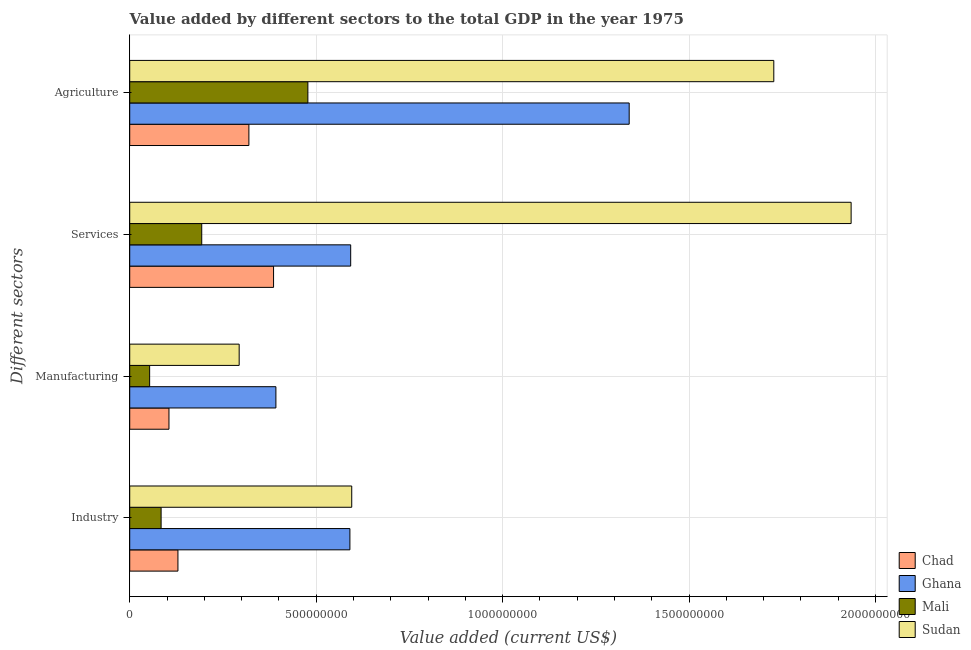How many groups of bars are there?
Your answer should be very brief. 4. Are the number of bars per tick equal to the number of legend labels?
Ensure brevity in your answer.  Yes. Are the number of bars on each tick of the Y-axis equal?
Make the answer very short. Yes. How many bars are there on the 3rd tick from the top?
Give a very brief answer. 4. How many bars are there on the 4th tick from the bottom?
Give a very brief answer. 4. What is the label of the 3rd group of bars from the top?
Your response must be concise. Manufacturing. What is the value added by services sector in Chad?
Your answer should be very brief. 3.86e+08. Across all countries, what is the maximum value added by services sector?
Your answer should be very brief. 1.93e+09. Across all countries, what is the minimum value added by industrial sector?
Keep it short and to the point. 8.42e+07. In which country was the value added by industrial sector maximum?
Ensure brevity in your answer.  Sudan. In which country was the value added by services sector minimum?
Provide a succinct answer. Mali. What is the total value added by industrial sector in the graph?
Offer a very short reply. 1.40e+09. What is the difference between the value added by industrial sector in Sudan and that in Chad?
Offer a very short reply. 4.66e+08. What is the difference between the value added by manufacturing sector in Chad and the value added by agricultural sector in Ghana?
Offer a terse response. -1.23e+09. What is the average value added by services sector per country?
Your response must be concise. 7.76e+08. What is the difference between the value added by agricultural sector and value added by manufacturing sector in Sudan?
Provide a short and direct response. 1.43e+09. In how many countries, is the value added by agricultural sector greater than 1600000000 US$?
Make the answer very short. 1. What is the ratio of the value added by agricultural sector in Mali to that in Chad?
Provide a short and direct response. 1.5. What is the difference between the highest and the second highest value added by industrial sector?
Provide a short and direct response. 4.92e+06. What is the difference between the highest and the lowest value added by agricultural sector?
Provide a succinct answer. 1.41e+09. Is it the case that in every country, the sum of the value added by industrial sector and value added by agricultural sector is greater than the sum of value added by manufacturing sector and value added by services sector?
Provide a short and direct response. No. What does the 4th bar from the top in Agriculture represents?
Offer a very short reply. Chad. What does the 4th bar from the bottom in Manufacturing represents?
Give a very brief answer. Sudan. Is it the case that in every country, the sum of the value added by industrial sector and value added by manufacturing sector is greater than the value added by services sector?
Ensure brevity in your answer.  No. What is the difference between two consecutive major ticks on the X-axis?
Offer a terse response. 5.00e+08. Are the values on the major ticks of X-axis written in scientific E-notation?
Your response must be concise. No. How many legend labels are there?
Give a very brief answer. 4. How are the legend labels stacked?
Your answer should be very brief. Vertical. What is the title of the graph?
Provide a short and direct response. Value added by different sectors to the total GDP in the year 1975. Does "Switzerland" appear as one of the legend labels in the graph?
Your response must be concise. No. What is the label or title of the X-axis?
Keep it short and to the point. Value added (current US$). What is the label or title of the Y-axis?
Provide a succinct answer. Different sectors. What is the Value added (current US$) in Chad in Industry?
Make the answer very short. 1.29e+08. What is the Value added (current US$) in Ghana in Industry?
Make the answer very short. 5.90e+08. What is the Value added (current US$) of Mali in Industry?
Ensure brevity in your answer.  8.42e+07. What is the Value added (current US$) in Sudan in Industry?
Offer a terse response. 5.95e+08. What is the Value added (current US$) in Chad in Manufacturing?
Your response must be concise. 1.05e+08. What is the Value added (current US$) of Ghana in Manufacturing?
Make the answer very short. 3.92e+08. What is the Value added (current US$) of Mali in Manufacturing?
Ensure brevity in your answer.  5.34e+07. What is the Value added (current US$) in Sudan in Manufacturing?
Your answer should be compact. 2.94e+08. What is the Value added (current US$) of Chad in Services?
Give a very brief answer. 3.86e+08. What is the Value added (current US$) of Ghana in Services?
Provide a short and direct response. 5.93e+08. What is the Value added (current US$) in Mali in Services?
Your answer should be compact. 1.93e+08. What is the Value added (current US$) in Sudan in Services?
Ensure brevity in your answer.  1.93e+09. What is the Value added (current US$) of Chad in Agriculture?
Your answer should be very brief. 3.20e+08. What is the Value added (current US$) in Ghana in Agriculture?
Make the answer very short. 1.34e+09. What is the Value added (current US$) in Mali in Agriculture?
Your answer should be very brief. 4.78e+08. What is the Value added (current US$) of Sudan in Agriculture?
Make the answer very short. 1.73e+09. Across all Different sectors, what is the maximum Value added (current US$) of Chad?
Provide a short and direct response. 3.86e+08. Across all Different sectors, what is the maximum Value added (current US$) of Ghana?
Provide a short and direct response. 1.34e+09. Across all Different sectors, what is the maximum Value added (current US$) in Mali?
Offer a very short reply. 4.78e+08. Across all Different sectors, what is the maximum Value added (current US$) of Sudan?
Your response must be concise. 1.93e+09. Across all Different sectors, what is the minimum Value added (current US$) of Chad?
Your answer should be very brief. 1.05e+08. Across all Different sectors, what is the minimum Value added (current US$) of Ghana?
Your response must be concise. 3.92e+08. Across all Different sectors, what is the minimum Value added (current US$) in Mali?
Ensure brevity in your answer.  5.34e+07. Across all Different sectors, what is the minimum Value added (current US$) in Sudan?
Ensure brevity in your answer.  2.94e+08. What is the total Value added (current US$) of Chad in the graph?
Keep it short and to the point. 9.40e+08. What is the total Value added (current US$) of Ghana in the graph?
Provide a short and direct response. 2.91e+09. What is the total Value added (current US$) in Mali in the graph?
Provide a succinct answer. 8.08e+08. What is the total Value added (current US$) in Sudan in the graph?
Provide a succinct answer. 4.55e+09. What is the difference between the Value added (current US$) of Chad in Industry and that in Manufacturing?
Make the answer very short. 2.41e+07. What is the difference between the Value added (current US$) of Ghana in Industry and that in Manufacturing?
Provide a short and direct response. 1.98e+08. What is the difference between the Value added (current US$) of Mali in Industry and that in Manufacturing?
Keep it short and to the point. 3.08e+07. What is the difference between the Value added (current US$) in Sudan in Industry and that in Manufacturing?
Your answer should be compact. 3.02e+08. What is the difference between the Value added (current US$) in Chad in Industry and that in Services?
Provide a short and direct response. -2.56e+08. What is the difference between the Value added (current US$) in Ghana in Industry and that in Services?
Your response must be concise. -2.13e+06. What is the difference between the Value added (current US$) in Mali in Industry and that in Services?
Provide a succinct answer. -1.09e+08. What is the difference between the Value added (current US$) in Sudan in Industry and that in Services?
Offer a terse response. -1.34e+09. What is the difference between the Value added (current US$) in Chad in Industry and that in Agriculture?
Your response must be concise. -1.90e+08. What is the difference between the Value added (current US$) of Ghana in Industry and that in Agriculture?
Provide a short and direct response. -7.49e+08. What is the difference between the Value added (current US$) of Mali in Industry and that in Agriculture?
Provide a succinct answer. -3.94e+08. What is the difference between the Value added (current US$) in Sudan in Industry and that in Agriculture?
Make the answer very short. -1.13e+09. What is the difference between the Value added (current US$) of Chad in Manufacturing and that in Services?
Offer a terse response. -2.80e+08. What is the difference between the Value added (current US$) in Ghana in Manufacturing and that in Services?
Provide a short and direct response. -2.01e+08. What is the difference between the Value added (current US$) of Mali in Manufacturing and that in Services?
Provide a short and direct response. -1.40e+08. What is the difference between the Value added (current US$) of Sudan in Manufacturing and that in Services?
Your answer should be very brief. -1.64e+09. What is the difference between the Value added (current US$) of Chad in Manufacturing and that in Agriculture?
Provide a succinct answer. -2.14e+08. What is the difference between the Value added (current US$) in Ghana in Manufacturing and that in Agriculture?
Provide a succinct answer. -9.47e+08. What is the difference between the Value added (current US$) in Mali in Manufacturing and that in Agriculture?
Keep it short and to the point. -4.24e+08. What is the difference between the Value added (current US$) of Sudan in Manufacturing and that in Agriculture?
Your answer should be very brief. -1.43e+09. What is the difference between the Value added (current US$) in Chad in Services and that in Agriculture?
Keep it short and to the point. 6.62e+07. What is the difference between the Value added (current US$) in Ghana in Services and that in Agriculture?
Keep it short and to the point. -7.47e+08. What is the difference between the Value added (current US$) of Mali in Services and that in Agriculture?
Provide a succinct answer. -2.85e+08. What is the difference between the Value added (current US$) in Sudan in Services and that in Agriculture?
Your answer should be very brief. 2.07e+08. What is the difference between the Value added (current US$) in Chad in Industry and the Value added (current US$) in Ghana in Manufacturing?
Your answer should be very brief. -2.63e+08. What is the difference between the Value added (current US$) of Chad in Industry and the Value added (current US$) of Mali in Manufacturing?
Provide a short and direct response. 7.59e+07. What is the difference between the Value added (current US$) in Chad in Industry and the Value added (current US$) in Sudan in Manufacturing?
Your response must be concise. -1.64e+08. What is the difference between the Value added (current US$) of Ghana in Industry and the Value added (current US$) of Mali in Manufacturing?
Keep it short and to the point. 5.37e+08. What is the difference between the Value added (current US$) in Ghana in Industry and the Value added (current US$) in Sudan in Manufacturing?
Offer a terse response. 2.97e+08. What is the difference between the Value added (current US$) in Mali in Industry and the Value added (current US$) in Sudan in Manufacturing?
Provide a succinct answer. -2.09e+08. What is the difference between the Value added (current US$) of Chad in Industry and the Value added (current US$) of Ghana in Services?
Ensure brevity in your answer.  -4.63e+08. What is the difference between the Value added (current US$) in Chad in Industry and the Value added (current US$) in Mali in Services?
Provide a succinct answer. -6.38e+07. What is the difference between the Value added (current US$) of Chad in Industry and the Value added (current US$) of Sudan in Services?
Your response must be concise. -1.81e+09. What is the difference between the Value added (current US$) in Ghana in Industry and the Value added (current US$) in Mali in Services?
Ensure brevity in your answer.  3.97e+08. What is the difference between the Value added (current US$) of Ghana in Industry and the Value added (current US$) of Sudan in Services?
Your answer should be compact. -1.34e+09. What is the difference between the Value added (current US$) in Mali in Industry and the Value added (current US$) in Sudan in Services?
Ensure brevity in your answer.  -1.85e+09. What is the difference between the Value added (current US$) in Chad in Industry and the Value added (current US$) in Ghana in Agriculture?
Your response must be concise. -1.21e+09. What is the difference between the Value added (current US$) in Chad in Industry and the Value added (current US$) in Mali in Agriculture?
Make the answer very short. -3.48e+08. What is the difference between the Value added (current US$) of Chad in Industry and the Value added (current US$) of Sudan in Agriculture?
Provide a short and direct response. -1.60e+09. What is the difference between the Value added (current US$) in Ghana in Industry and the Value added (current US$) in Mali in Agriculture?
Offer a very short reply. 1.13e+08. What is the difference between the Value added (current US$) in Ghana in Industry and the Value added (current US$) in Sudan in Agriculture?
Make the answer very short. -1.14e+09. What is the difference between the Value added (current US$) of Mali in Industry and the Value added (current US$) of Sudan in Agriculture?
Provide a short and direct response. -1.64e+09. What is the difference between the Value added (current US$) of Chad in Manufacturing and the Value added (current US$) of Ghana in Services?
Your answer should be very brief. -4.87e+08. What is the difference between the Value added (current US$) of Chad in Manufacturing and the Value added (current US$) of Mali in Services?
Offer a terse response. -8.79e+07. What is the difference between the Value added (current US$) in Chad in Manufacturing and the Value added (current US$) in Sudan in Services?
Your answer should be compact. -1.83e+09. What is the difference between the Value added (current US$) in Ghana in Manufacturing and the Value added (current US$) in Mali in Services?
Make the answer very short. 1.99e+08. What is the difference between the Value added (current US$) of Ghana in Manufacturing and the Value added (current US$) of Sudan in Services?
Provide a succinct answer. -1.54e+09. What is the difference between the Value added (current US$) of Mali in Manufacturing and the Value added (current US$) of Sudan in Services?
Your answer should be compact. -1.88e+09. What is the difference between the Value added (current US$) in Chad in Manufacturing and the Value added (current US$) in Ghana in Agriculture?
Provide a short and direct response. -1.23e+09. What is the difference between the Value added (current US$) of Chad in Manufacturing and the Value added (current US$) of Mali in Agriculture?
Make the answer very short. -3.72e+08. What is the difference between the Value added (current US$) in Chad in Manufacturing and the Value added (current US$) in Sudan in Agriculture?
Provide a succinct answer. -1.62e+09. What is the difference between the Value added (current US$) in Ghana in Manufacturing and the Value added (current US$) in Mali in Agriculture?
Ensure brevity in your answer.  -8.57e+07. What is the difference between the Value added (current US$) in Ghana in Manufacturing and the Value added (current US$) in Sudan in Agriculture?
Provide a short and direct response. -1.34e+09. What is the difference between the Value added (current US$) in Mali in Manufacturing and the Value added (current US$) in Sudan in Agriculture?
Give a very brief answer. -1.67e+09. What is the difference between the Value added (current US$) of Chad in Services and the Value added (current US$) of Ghana in Agriculture?
Your answer should be compact. -9.54e+08. What is the difference between the Value added (current US$) in Chad in Services and the Value added (current US$) in Mali in Agriculture?
Provide a succinct answer. -9.20e+07. What is the difference between the Value added (current US$) in Chad in Services and the Value added (current US$) in Sudan in Agriculture?
Offer a terse response. -1.34e+09. What is the difference between the Value added (current US$) in Ghana in Services and the Value added (current US$) in Mali in Agriculture?
Keep it short and to the point. 1.15e+08. What is the difference between the Value added (current US$) in Ghana in Services and the Value added (current US$) in Sudan in Agriculture?
Your answer should be very brief. -1.13e+09. What is the difference between the Value added (current US$) of Mali in Services and the Value added (current US$) of Sudan in Agriculture?
Provide a short and direct response. -1.53e+09. What is the average Value added (current US$) in Chad per Different sectors?
Give a very brief answer. 2.35e+08. What is the average Value added (current US$) of Ghana per Different sectors?
Keep it short and to the point. 7.29e+08. What is the average Value added (current US$) of Mali per Different sectors?
Keep it short and to the point. 2.02e+08. What is the average Value added (current US$) of Sudan per Different sectors?
Provide a short and direct response. 1.14e+09. What is the difference between the Value added (current US$) in Chad and Value added (current US$) in Ghana in Industry?
Offer a very short reply. -4.61e+08. What is the difference between the Value added (current US$) of Chad and Value added (current US$) of Mali in Industry?
Your answer should be compact. 4.51e+07. What is the difference between the Value added (current US$) of Chad and Value added (current US$) of Sudan in Industry?
Your answer should be compact. -4.66e+08. What is the difference between the Value added (current US$) in Ghana and Value added (current US$) in Mali in Industry?
Give a very brief answer. 5.06e+08. What is the difference between the Value added (current US$) of Ghana and Value added (current US$) of Sudan in Industry?
Provide a short and direct response. -4.92e+06. What is the difference between the Value added (current US$) of Mali and Value added (current US$) of Sudan in Industry?
Your answer should be very brief. -5.11e+08. What is the difference between the Value added (current US$) of Chad and Value added (current US$) of Ghana in Manufacturing?
Your answer should be very brief. -2.87e+08. What is the difference between the Value added (current US$) of Chad and Value added (current US$) of Mali in Manufacturing?
Keep it short and to the point. 5.18e+07. What is the difference between the Value added (current US$) in Chad and Value added (current US$) in Sudan in Manufacturing?
Your answer should be compact. -1.88e+08. What is the difference between the Value added (current US$) in Ghana and Value added (current US$) in Mali in Manufacturing?
Your answer should be very brief. 3.39e+08. What is the difference between the Value added (current US$) of Ghana and Value added (current US$) of Sudan in Manufacturing?
Provide a succinct answer. 9.85e+07. What is the difference between the Value added (current US$) in Mali and Value added (current US$) in Sudan in Manufacturing?
Keep it short and to the point. -2.40e+08. What is the difference between the Value added (current US$) in Chad and Value added (current US$) in Ghana in Services?
Your answer should be very brief. -2.07e+08. What is the difference between the Value added (current US$) in Chad and Value added (current US$) in Mali in Services?
Your answer should be compact. 1.93e+08. What is the difference between the Value added (current US$) of Chad and Value added (current US$) of Sudan in Services?
Offer a very short reply. -1.55e+09. What is the difference between the Value added (current US$) in Ghana and Value added (current US$) in Mali in Services?
Make the answer very short. 3.99e+08. What is the difference between the Value added (current US$) in Ghana and Value added (current US$) in Sudan in Services?
Keep it short and to the point. -1.34e+09. What is the difference between the Value added (current US$) of Mali and Value added (current US$) of Sudan in Services?
Give a very brief answer. -1.74e+09. What is the difference between the Value added (current US$) in Chad and Value added (current US$) in Ghana in Agriculture?
Your answer should be very brief. -1.02e+09. What is the difference between the Value added (current US$) in Chad and Value added (current US$) in Mali in Agriculture?
Your response must be concise. -1.58e+08. What is the difference between the Value added (current US$) of Chad and Value added (current US$) of Sudan in Agriculture?
Make the answer very short. -1.41e+09. What is the difference between the Value added (current US$) in Ghana and Value added (current US$) in Mali in Agriculture?
Ensure brevity in your answer.  8.62e+08. What is the difference between the Value added (current US$) of Ghana and Value added (current US$) of Sudan in Agriculture?
Ensure brevity in your answer.  -3.88e+08. What is the difference between the Value added (current US$) in Mali and Value added (current US$) in Sudan in Agriculture?
Your answer should be compact. -1.25e+09. What is the ratio of the Value added (current US$) in Chad in Industry to that in Manufacturing?
Offer a very short reply. 1.23. What is the ratio of the Value added (current US$) in Ghana in Industry to that in Manufacturing?
Give a very brief answer. 1.51. What is the ratio of the Value added (current US$) in Mali in Industry to that in Manufacturing?
Give a very brief answer. 1.58. What is the ratio of the Value added (current US$) in Sudan in Industry to that in Manufacturing?
Offer a terse response. 2.03. What is the ratio of the Value added (current US$) of Chad in Industry to that in Services?
Your response must be concise. 0.34. What is the ratio of the Value added (current US$) of Ghana in Industry to that in Services?
Provide a succinct answer. 1. What is the ratio of the Value added (current US$) of Mali in Industry to that in Services?
Offer a very short reply. 0.44. What is the ratio of the Value added (current US$) in Sudan in Industry to that in Services?
Offer a terse response. 0.31. What is the ratio of the Value added (current US$) of Chad in Industry to that in Agriculture?
Keep it short and to the point. 0.4. What is the ratio of the Value added (current US$) of Ghana in Industry to that in Agriculture?
Make the answer very short. 0.44. What is the ratio of the Value added (current US$) in Mali in Industry to that in Agriculture?
Make the answer very short. 0.18. What is the ratio of the Value added (current US$) of Sudan in Industry to that in Agriculture?
Make the answer very short. 0.34. What is the ratio of the Value added (current US$) in Chad in Manufacturing to that in Services?
Offer a terse response. 0.27. What is the ratio of the Value added (current US$) of Ghana in Manufacturing to that in Services?
Keep it short and to the point. 0.66. What is the ratio of the Value added (current US$) of Mali in Manufacturing to that in Services?
Your answer should be compact. 0.28. What is the ratio of the Value added (current US$) in Sudan in Manufacturing to that in Services?
Make the answer very short. 0.15. What is the ratio of the Value added (current US$) in Chad in Manufacturing to that in Agriculture?
Ensure brevity in your answer.  0.33. What is the ratio of the Value added (current US$) of Ghana in Manufacturing to that in Agriculture?
Make the answer very short. 0.29. What is the ratio of the Value added (current US$) of Mali in Manufacturing to that in Agriculture?
Offer a very short reply. 0.11. What is the ratio of the Value added (current US$) in Sudan in Manufacturing to that in Agriculture?
Provide a succinct answer. 0.17. What is the ratio of the Value added (current US$) in Chad in Services to that in Agriculture?
Give a very brief answer. 1.21. What is the ratio of the Value added (current US$) in Ghana in Services to that in Agriculture?
Ensure brevity in your answer.  0.44. What is the ratio of the Value added (current US$) in Mali in Services to that in Agriculture?
Make the answer very short. 0.4. What is the ratio of the Value added (current US$) of Sudan in Services to that in Agriculture?
Provide a short and direct response. 1.12. What is the difference between the highest and the second highest Value added (current US$) in Chad?
Ensure brevity in your answer.  6.62e+07. What is the difference between the highest and the second highest Value added (current US$) in Ghana?
Your answer should be very brief. 7.47e+08. What is the difference between the highest and the second highest Value added (current US$) in Mali?
Your answer should be very brief. 2.85e+08. What is the difference between the highest and the second highest Value added (current US$) in Sudan?
Offer a terse response. 2.07e+08. What is the difference between the highest and the lowest Value added (current US$) of Chad?
Offer a terse response. 2.80e+08. What is the difference between the highest and the lowest Value added (current US$) of Ghana?
Provide a succinct answer. 9.47e+08. What is the difference between the highest and the lowest Value added (current US$) in Mali?
Your answer should be very brief. 4.24e+08. What is the difference between the highest and the lowest Value added (current US$) of Sudan?
Give a very brief answer. 1.64e+09. 